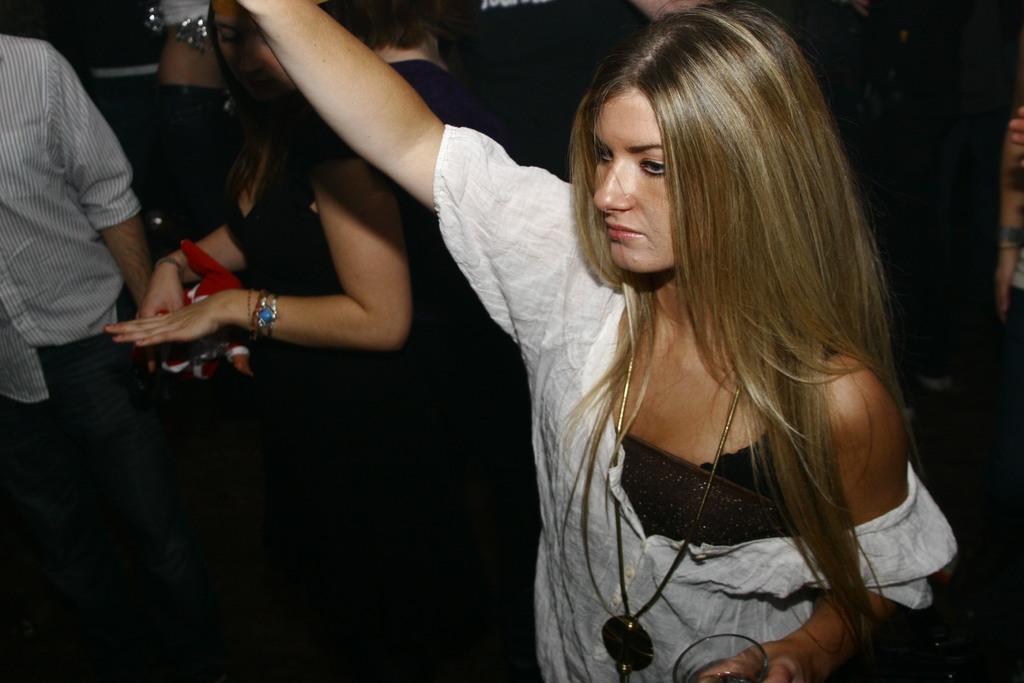How would you summarize this image in a sentence or two? In this image I can see the group of people with different color dresses. I can see one person holding the glass. And there is a black background. 